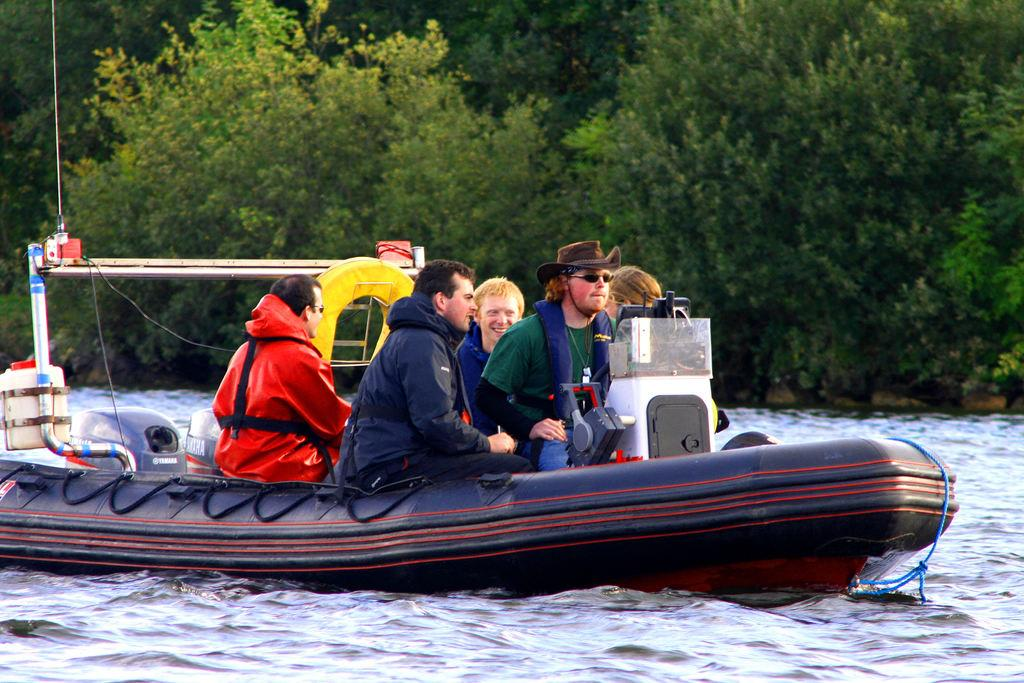What is the main subject of the image? The image depicts a river. What are the people in the image doing? The people are sitting on a boat. Is there a boat in the image? Yes, there is a boat on the water. What can be seen in the background of the image? Trees are visible in the background of the image. What type of underwear is the group of people wearing in the image? There is no information about the underwear of the people in the image, as the focus is on their activity on the boat. --- Facts: 1. There is a car in the image. 2. The car is parked on the street. 3. There are streetlights in the image. 4. The street is visible in the image. 5. There are buildings in the background of the image. Absurd Topics: dance, rainbow, parrot Conversation: What is the main subject of the image? The main subject of the image is a car. Where is the car located in the image? The car is parked on the street. What else can be seen in the image besides the car? There are streetlights, the street, and buildings in the background of the image. Reasoning: Let's think step by step in order to produce the conversation. We start by identifying the main subject of the image, which is the car. Then, we describe the location of the car, noting that it is parked on the street. Next, we mention other elements in the image, such as streetlights, the street, and buildings in the background. Absurd Question/Answer: Can you see a rainbow in the image? No, there is no rainbow present in the image. Is there a parrot sitting on the car in the image? No, there is no parrot present in the image. 